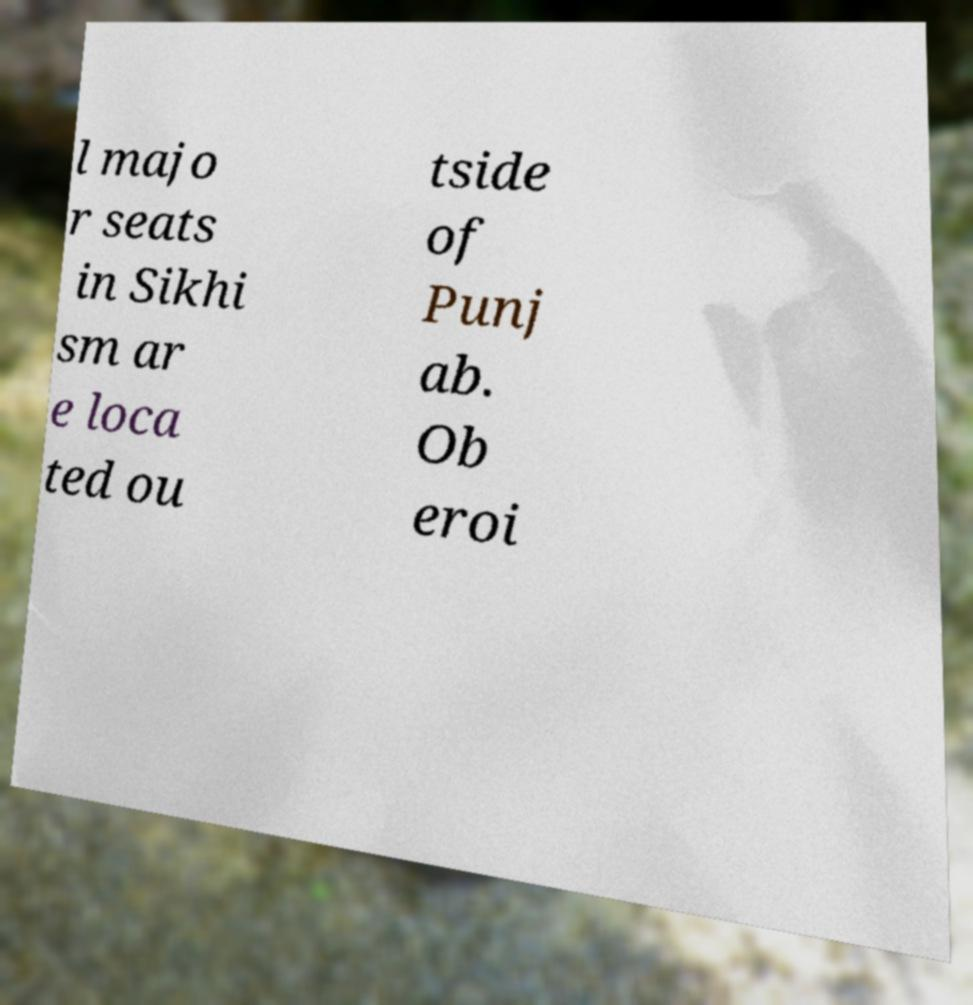Can you read and provide the text displayed in the image?This photo seems to have some interesting text. Can you extract and type it out for me? l majo r seats in Sikhi sm ar e loca ted ou tside of Punj ab. Ob eroi 